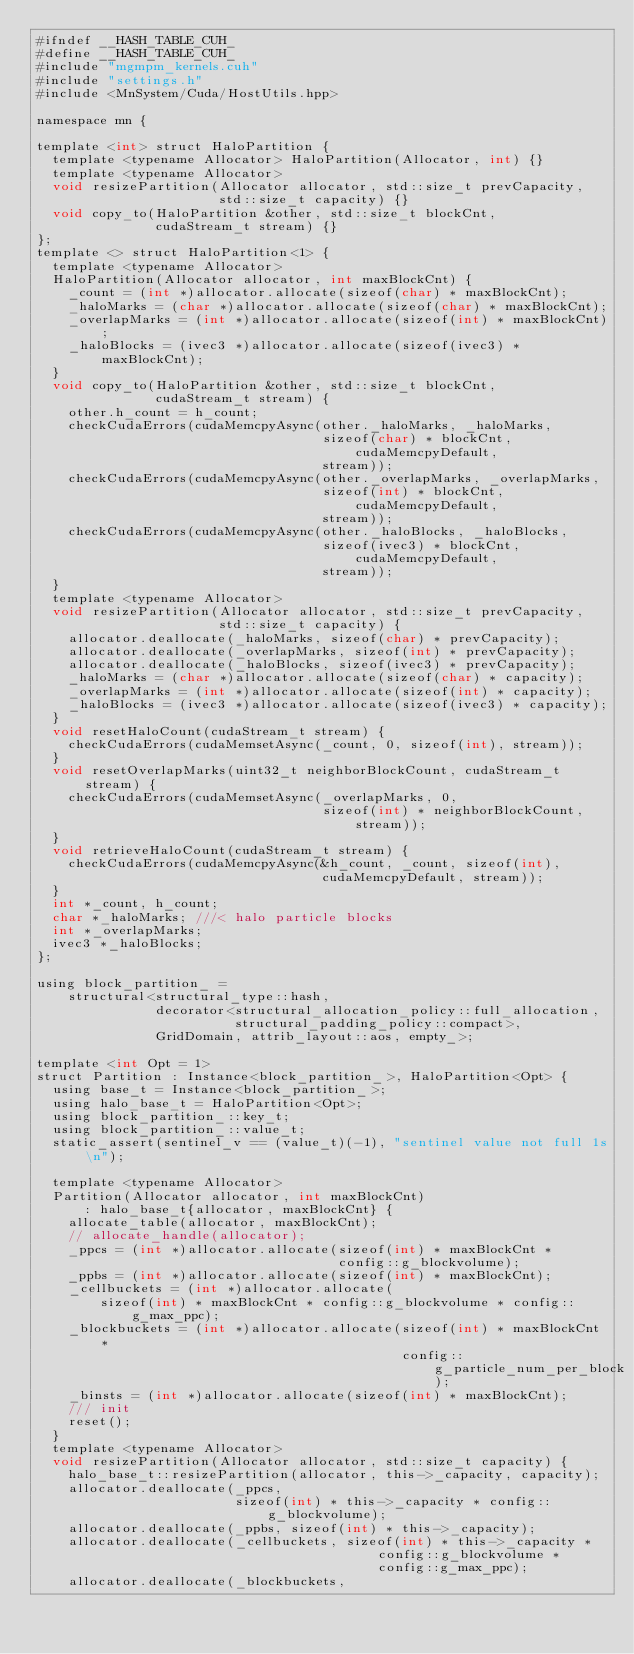Convert code to text. <code><loc_0><loc_0><loc_500><loc_500><_Cuda_>#ifndef __HASH_TABLE_CUH_
#define __HASH_TABLE_CUH_
#include "mgmpm_kernels.cuh"
#include "settings.h"
#include <MnSystem/Cuda/HostUtils.hpp>

namespace mn {

template <int> struct HaloPartition {
  template <typename Allocator> HaloPartition(Allocator, int) {}
  template <typename Allocator>
  void resizePartition(Allocator allocator, std::size_t prevCapacity,
                       std::size_t capacity) {}
  void copy_to(HaloPartition &other, std::size_t blockCnt,
               cudaStream_t stream) {}
};
template <> struct HaloPartition<1> {
  template <typename Allocator>
  HaloPartition(Allocator allocator, int maxBlockCnt) {
    _count = (int *)allocator.allocate(sizeof(char) * maxBlockCnt);
    _haloMarks = (char *)allocator.allocate(sizeof(char) * maxBlockCnt);
    _overlapMarks = (int *)allocator.allocate(sizeof(int) * maxBlockCnt);
    _haloBlocks = (ivec3 *)allocator.allocate(sizeof(ivec3) * maxBlockCnt);
  }
  void copy_to(HaloPartition &other, std::size_t blockCnt,
               cudaStream_t stream) {
    other.h_count = h_count;
    checkCudaErrors(cudaMemcpyAsync(other._haloMarks, _haloMarks,
                                    sizeof(char) * blockCnt, cudaMemcpyDefault,
                                    stream));
    checkCudaErrors(cudaMemcpyAsync(other._overlapMarks, _overlapMarks,
                                    sizeof(int) * blockCnt, cudaMemcpyDefault,
                                    stream));
    checkCudaErrors(cudaMemcpyAsync(other._haloBlocks, _haloBlocks,
                                    sizeof(ivec3) * blockCnt, cudaMemcpyDefault,
                                    stream));
  }
  template <typename Allocator>
  void resizePartition(Allocator allocator, std::size_t prevCapacity,
                       std::size_t capacity) {
    allocator.deallocate(_haloMarks, sizeof(char) * prevCapacity);
    allocator.deallocate(_overlapMarks, sizeof(int) * prevCapacity);
    allocator.deallocate(_haloBlocks, sizeof(ivec3) * prevCapacity);
    _haloMarks = (char *)allocator.allocate(sizeof(char) * capacity);
    _overlapMarks = (int *)allocator.allocate(sizeof(int) * capacity);
    _haloBlocks = (ivec3 *)allocator.allocate(sizeof(ivec3) * capacity);
  }
  void resetHaloCount(cudaStream_t stream) {
    checkCudaErrors(cudaMemsetAsync(_count, 0, sizeof(int), stream));
  }
  void resetOverlapMarks(uint32_t neighborBlockCount, cudaStream_t stream) {
    checkCudaErrors(cudaMemsetAsync(_overlapMarks, 0,
                                    sizeof(int) * neighborBlockCount, stream));
  }
  void retrieveHaloCount(cudaStream_t stream) {
    checkCudaErrors(cudaMemcpyAsync(&h_count, _count, sizeof(int),
                                    cudaMemcpyDefault, stream));
  }
  int *_count, h_count;
  char *_haloMarks; ///< halo particle blocks
  int *_overlapMarks;
  ivec3 *_haloBlocks;
};

using block_partition_ =
    structural<structural_type::hash,
               decorator<structural_allocation_policy::full_allocation,
                         structural_padding_policy::compact>,
               GridDomain, attrib_layout::aos, empty_>;

template <int Opt = 1>
struct Partition : Instance<block_partition_>, HaloPartition<Opt> {
  using base_t = Instance<block_partition_>;
  using halo_base_t = HaloPartition<Opt>;
  using block_partition_::key_t;
  using block_partition_::value_t;
  static_assert(sentinel_v == (value_t)(-1), "sentinel value not full 1s\n");

  template <typename Allocator>
  Partition(Allocator allocator, int maxBlockCnt)
      : halo_base_t{allocator, maxBlockCnt} {
    allocate_table(allocator, maxBlockCnt);
    // allocate_handle(allocator);
    _ppcs = (int *)allocator.allocate(sizeof(int) * maxBlockCnt *
                                      config::g_blockvolume);
    _ppbs = (int *)allocator.allocate(sizeof(int) * maxBlockCnt);
    _cellbuckets = (int *)allocator.allocate(
        sizeof(int) * maxBlockCnt * config::g_blockvolume * config::g_max_ppc);
    _blockbuckets = (int *)allocator.allocate(sizeof(int) * maxBlockCnt *
                                              config::g_particle_num_per_block);
    _binsts = (int *)allocator.allocate(sizeof(int) * maxBlockCnt);
    /// init
    reset();
  }
  template <typename Allocator>
  void resizePartition(Allocator allocator, std::size_t capacity) {
    halo_base_t::resizePartition(allocator, this->_capacity, capacity);
    allocator.deallocate(_ppcs,
                         sizeof(int) * this->_capacity * config::g_blockvolume);
    allocator.deallocate(_ppbs, sizeof(int) * this->_capacity);
    allocator.deallocate(_cellbuckets, sizeof(int) * this->_capacity *
                                           config::g_blockvolume *
                                           config::g_max_ppc);
    allocator.deallocate(_blockbuckets,</code> 